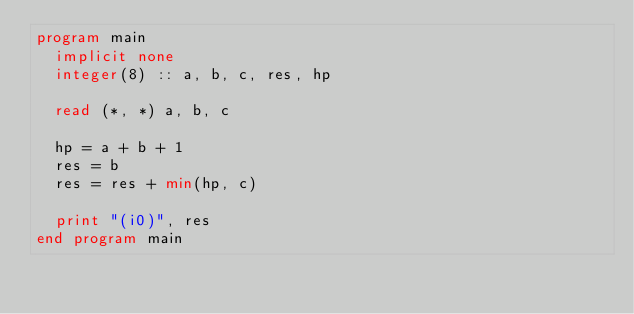Convert code to text. <code><loc_0><loc_0><loc_500><loc_500><_FORTRAN_>program main
  implicit none
  integer(8) :: a, b, c, res, hp

  read (*, *) a, b, c

  hp = a + b + 1
  res = b
  res = res + min(hp, c)

  print "(i0)", res
end program main
</code> 